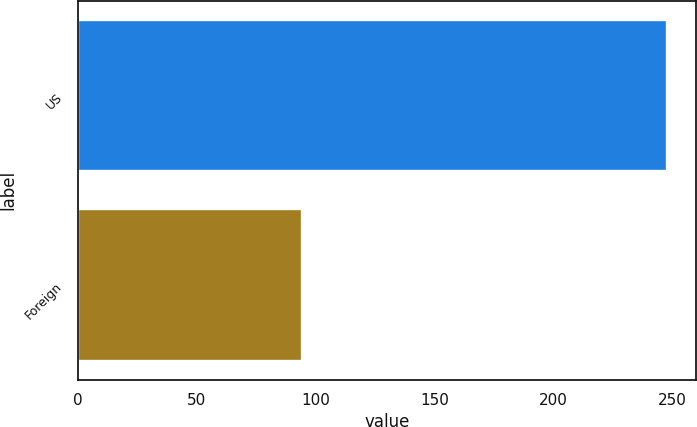<chart> <loc_0><loc_0><loc_500><loc_500><bar_chart><fcel>US<fcel>Foreign<nl><fcel>247.9<fcel>94.2<nl></chart> 